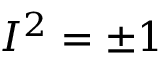<formula> <loc_0><loc_0><loc_500><loc_500>I ^ { 2 } = \pm 1</formula> 